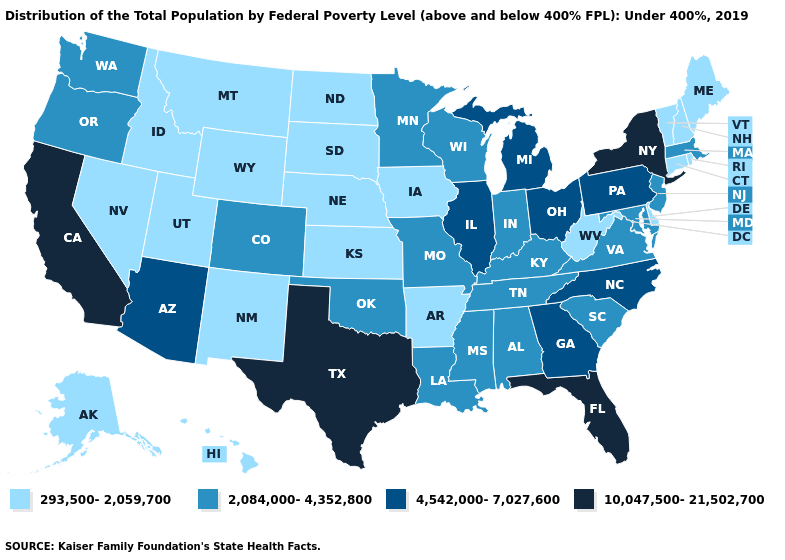Name the states that have a value in the range 10,047,500-21,502,700?
Quick response, please. California, Florida, New York, Texas. What is the lowest value in states that border Illinois?
Answer briefly. 293,500-2,059,700. Which states have the lowest value in the USA?
Short answer required. Alaska, Arkansas, Connecticut, Delaware, Hawaii, Idaho, Iowa, Kansas, Maine, Montana, Nebraska, Nevada, New Hampshire, New Mexico, North Dakota, Rhode Island, South Dakota, Utah, Vermont, West Virginia, Wyoming. What is the value of Texas?
Short answer required. 10,047,500-21,502,700. What is the highest value in states that border Wyoming?
Concise answer only. 2,084,000-4,352,800. Name the states that have a value in the range 10,047,500-21,502,700?
Write a very short answer. California, Florida, New York, Texas. What is the lowest value in the USA?
Concise answer only. 293,500-2,059,700. Does the map have missing data?
Keep it brief. No. Among the states that border New Hampshire , does Massachusetts have the lowest value?
Be succinct. No. What is the value of Alabama?
Concise answer only. 2,084,000-4,352,800. Name the states that have a value in the range 4,542,000-7,027,600?
Give a very brief answer. Arizona, Georgia, Illinois, Michigan, North Carolina, Ohio, Pennsylvania. Does West Virginia have the same value as Hawaii?
Answer briefly. Yes. Does Wyoming have the lowest value in the West?
Be succinct. Yes. How many symbols are there in the legend?
Quick response, please. 4. 